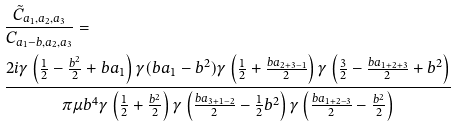Convert formula to latex. <formula><loc_0><loc_0><loc_500><loc_500>& \frac { \tilde { C } _ { a _ { 1 } , a _ { 2 } , a _ { 3 } } } { C _ { a _ { 1 } - b , a _ { 2 } , a _ { 3 } } } = \\ & \frac { 2 i \gamma \left ( \frac { 1 } { 2 } - \frac { b ^ { 2 } } 2 + b a _ { 1 } \right ) \gamma ( b a _ { 1 } - b ^ { 2 } ) \gamma \left ( \frac { 1 } { 2 } + \frac { b a _ { 2 + 3 - 1 } } 2 \right ) \gamma \left ( \frac { 3 } { 2 } - \frac { b a _ { 1 + 2 + 3 } } 2 + b ^ { 2 } \right ) } { \pi \mu b ^ { 4 } \gamma \left ( \frac { 1 } { 2 } + \frac { b ^ { 2 } } 2 \right ) \gamma \left ( \frac { b a _ { 3 + 1 - 2 } } 2 - \frac { 1 } { 2 } b ^ { 2 } \right ) \gamma \left ( \frac { b a _ { 1 + 2 - 3 } } 2 - \frac { b ^ { 2 } } 2 \right ) }</formula> 